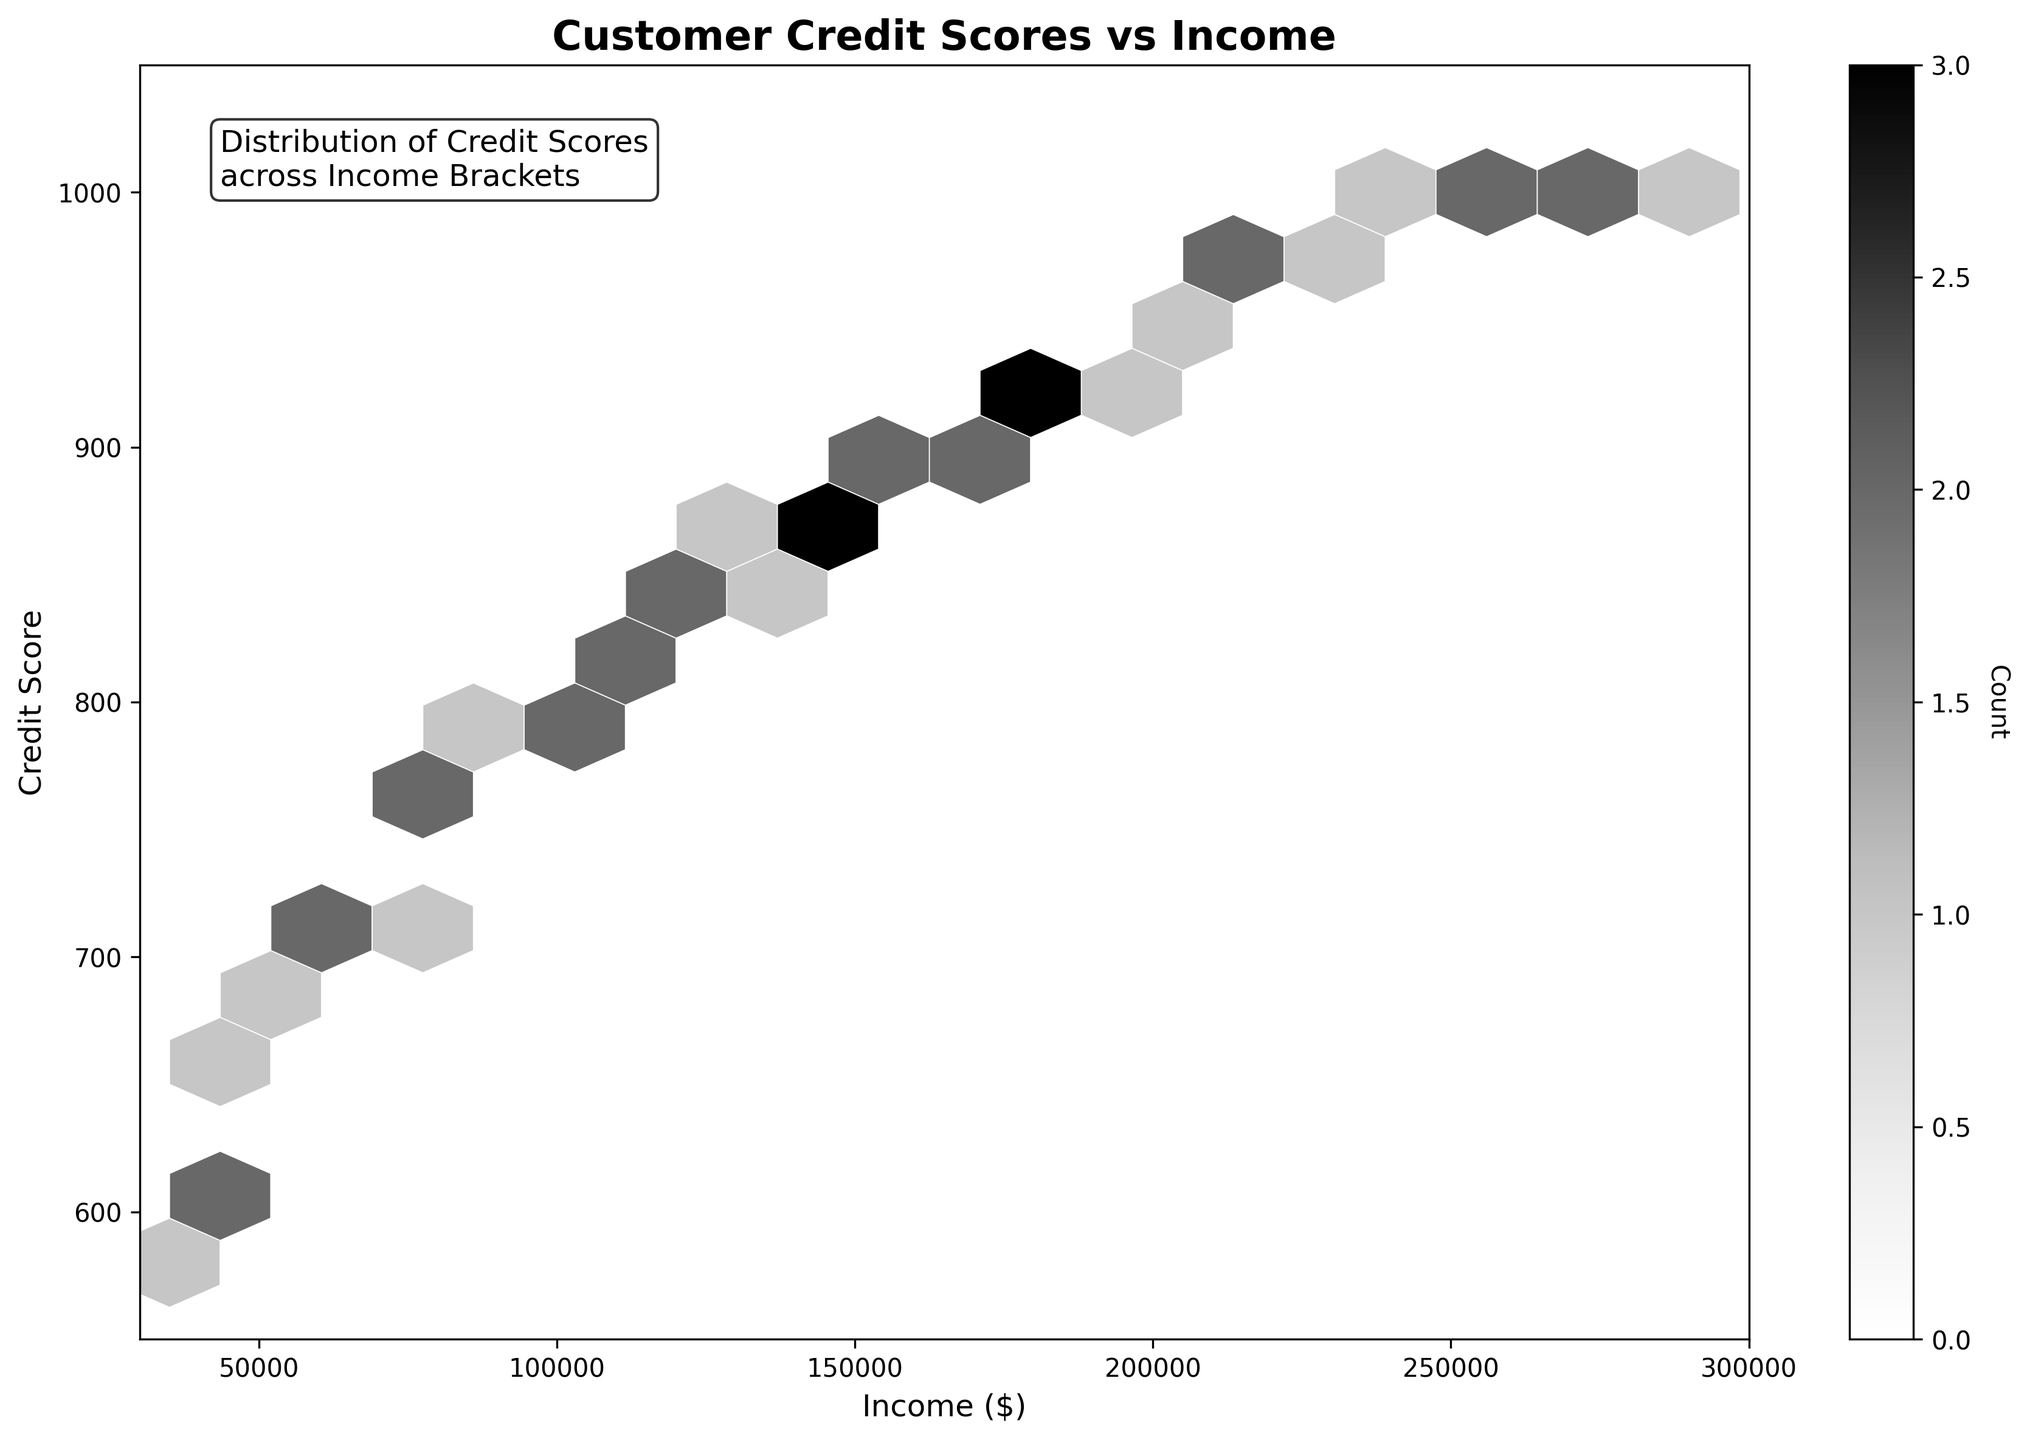How many data points are plotted in the figure? The total count of data points can be determined by examining the data. There are 40 rows in the dataset, meaning 40 data points are plotted.
Answer: 40 What does the color intensity in the hexagonal bins represent? The color intensity of each bin in the hexbin plot represents the density of data points within that bin. Darker bins indicate higher concentrations of data points.
Answer: Density What is the approximate range of income values presented in the plot? The x-axis represents income values, with limits set between $30,000 and $300,000. Observing the data points plotted, income values range approximately from $35,000 to $290,000.
Answer: $35,000 to $290,000 Where do the majority of data points concentrate with respect to income and credit score? The hexagonal bins with the darkest shades indicate the highest concentration. The plot shows that the majority of data points concentrate around the $100,000-$200,000 income range and the 800-900 credit score range.
Answer: Around $100,000-$200,000 income and 800-900 credit score How is the relationship between income and credit score depicted in the plot? The hexbin plot suggests a positive correlation between income and credit score. Higher income is generally associated with higher credit scores, as indicated by the upward trend in the bin densities.
Answer: Positive correlation Which income bracket has the highest credit score in the plot? By examining the data points and the hexagonal bins, the highest credit score of 1000 is found within the income brackets of $250,000 to $290,000.
Answer: $250,000 to $290,000 Do lower-income customers show a diverse range of credit scores or a more concentrated one? Observing the hexbin plot, lower-income brackets (around $30,000-$50,000) show a more concentrated range of credit scores, typically between 580 and 650, indicating less diversity.
Answer: Concentrated range Are there any noticeable outliers in the plot regarding credit scores? There are no significant outliers visible in the hexbin plot. All the data points fall within a continuous distribution without drastic deviations.
Answer: No What does the color bar on the side of the hexbin plot indicate? The color bar represents the count of data points within each hexagonal bin. Higher counts are indicated by darker colors, providing a reference for understanding density distribution.
Answer: Count of data points 